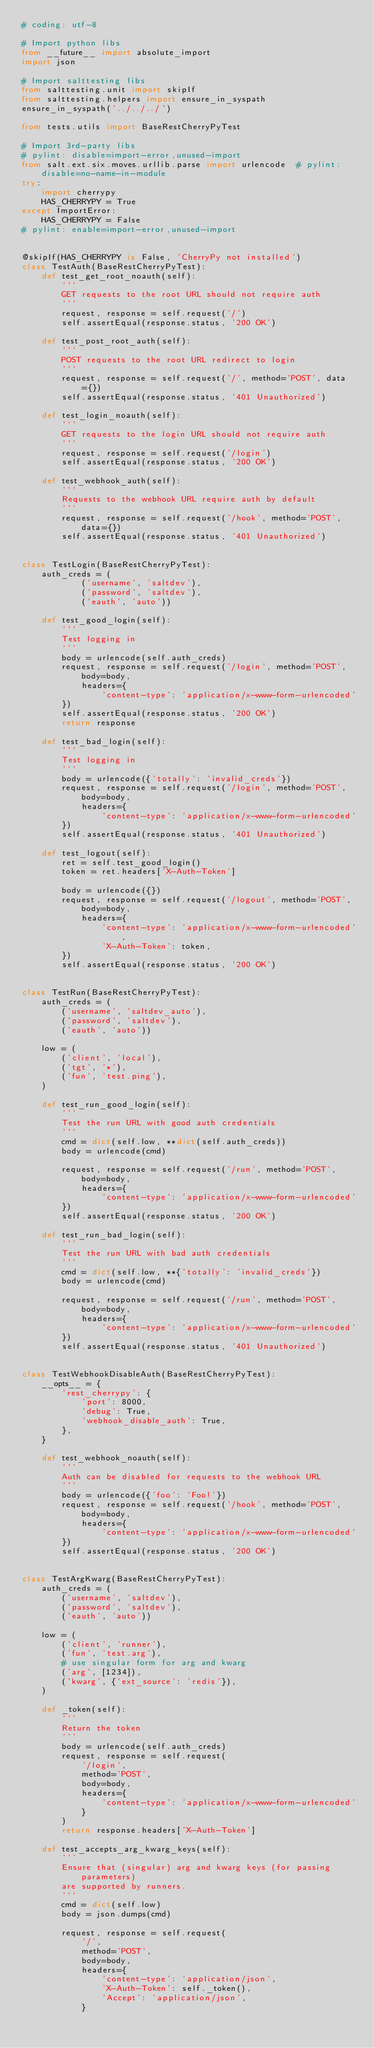Convert code to text. <code><loc_0><loc_0><loc_500><loc_500><_Python_># coding: utf-8

# Import python libs
from __future__ import absolute_import
import json

# Import salttesting libs
from salttesting.unit import skipIf
from salttesting.helpers import ensure_in_syspath
ensure_in_syspath('../../../')

from tests.utils import BaseRestCherryPyTest

# Import 3rd-party libs
# pylint: disable=import-error,unused-import
from salt.ext.six.moves.urllib.parse import urlencode  # pylint: disable=no-name-in-module
try:
    import cherrypy
    HAS_CHERRYPY = True
except ImportError:
    HAS_CHERRYPY = False
# pylint: enable=import-error,unused-import


@skipIf(HAS_CHERRYPY is False, 'CherryPy not installed')
class TestAuth(BaseRestCherryPyTest):
    def test_get_root_noauth(self):
        '''
        GET requests to the root URL should not require auth
        '''
        request, response = self.request('/')
        self.assertEqual(response.status, '200 OK')

    def test_post_root_auth(self):
        '''
        POST requests to the root URL redirect to login
        '''
        request, response = self.request('/', method='POST', data={})
        self.assertEqual(response.status, '401 Unauthorized')

    def test_login_noauth(self):
        '''
        GET requests to the login URL should not require auth
        '''
        request, response = self.request('/login')
        self.assertEqual(response.status, '200 OK')

    def test_webhook_auth(self):
        '''
        Requests to the webhook URL require auth by default
        '''
        request, response = self.request('/hook', method='POST', data={})
        self.assertEqual(response.status, '401 Unauthorized')


class TestLogin(BaseRestCherryPyTest):
    auth_creds = (
            ('username', 'saltdev'),
            ('password', 'saltdev'),
            ('eauth', 'auto'))

    def test_good_login(self):
        '''
        Test logging in
        '''
        body = urlencode(self.auth_creds)
        request, response = self.request('/login', method='POST', body=body,
            headers={
                'content-type': 'application/x-www-form-urlencoded'
        })
        self.assertEqual(response.status, '200 OK')
        return response

    def test_bad_login(self):
        '''
        Test logging in
        '''
        body = urlencode({'totally': 'invalid_creds'})
        request, response = self.request('/login', method='POST', body=body,
            headers={
                'content-type': 'application/x-www-form-urlencoded'
        })
        self.assertEqual(response.status, '401 Unauthorized')

    def test_logout(self):
        ret = self.test_good_login()
        token = ret.headers['X-Auth-Token']

        body = urlencode({})
        request, response = self.request('/logout', method='POST', body=body,
            headers={
                'content-type': 'application/x-www-form-urlencoded',
                'X-Auth-Token': token,
        })
        self.assertEqual(response.status, '200 OK')


class TestRun(BaseRestCherryPyTest):
    auth_creds = (
        ('username', 'saltdev_auto'),
        ('password', 'saltdev'),
        ('eauth', 'auto'))

    low = (
        ('client', 'local'),
        ('tgt', '*'),
        ('fun', 'test.ping'),
    )

    def test_run_good_login(self):
        '''
        Test the run URL with good auth credentials
        '''
        cmd = dict(self.low, **dict(self.auth_creds))
        body = urlencode(cmd)

        request, response = self.request('/run', method='POST', body=body,
            headers={
                'content-type': 'application/x-www-form-urlencoded'
        })
        self.assertEqual(response.status, '200 OK')

    def test_run_bad_login(self):
        '''
        Test the run URL with bad auth credentials
        '''
        cmd = dict(self.low, **{'totally': 'invalid_creds'})
        body = urlencode(cmd)

        request, response = self.request('/run', method='POST', body=body,
            headers={
                'content-type': 'application/x-www-form-urlencoded'
        })
        self.assertEqual(response.status, '401 Unauthorized')


class TestWebhookDisableAuth(BaseRestCherryPyTest):
    __opts__ = {
        'rest_cherrypy': {
            'port': 8000,
            'debug': True,
            'webhook_disable_auth': True,
        },
    }

    def test_webhook_noauth(self):
        '''
        Auth can be disabled for requests to the webhook URL
        '''
        body = urlencode({'foo': 'Foo!'})
        request, response = self.request('/hook', method='POST', body=body,
            headers={
                'content-type': 'application/x-www-form-urlencoded'
        })
        self.assertEqual(response.status, '200 OK')


class TestArgKwarg(BaseRestCherryPyTest):
    auth_creds = (
        ('username', 'saltdev'),
        ('password', 'saltdev'),
        ('eauth', 'auto'))

    low = (
        ('client', 'runner'),
        ('fun', 'test.arg'),
        # use singular form for arg and kwarg
        ('arg', [1234]),
        ('kwarg', {'ext_source': 'redis'}),
    )

    def _token(self):
        '''
        Return the token
        '''
        body = urlencode(self.auth_creds)
        request, response = self.request(
            '/login',
            method='POST',
            body=body,
            headers={
                'content-type': 'application/x-www-form-urlencoded'
            }
        )
        return response.headers['X-Auth-Token']

    def test_accepts_arg_kwarg_keys(self):
        '''
        Ensure that (singular) arg and kwarg keys (for passing parameters)
        are supported by runners.
        '''
        cmd = dict(self.low)
        body = json.dumps(cmd)

        request, response = self.request(
            '/',
            method='POST',
            body=body,
            headers={
                'content-type': 'application/json',
                'X-Auth-Token': self._token(),
                'Accept': 'application/json',
            }</code> 